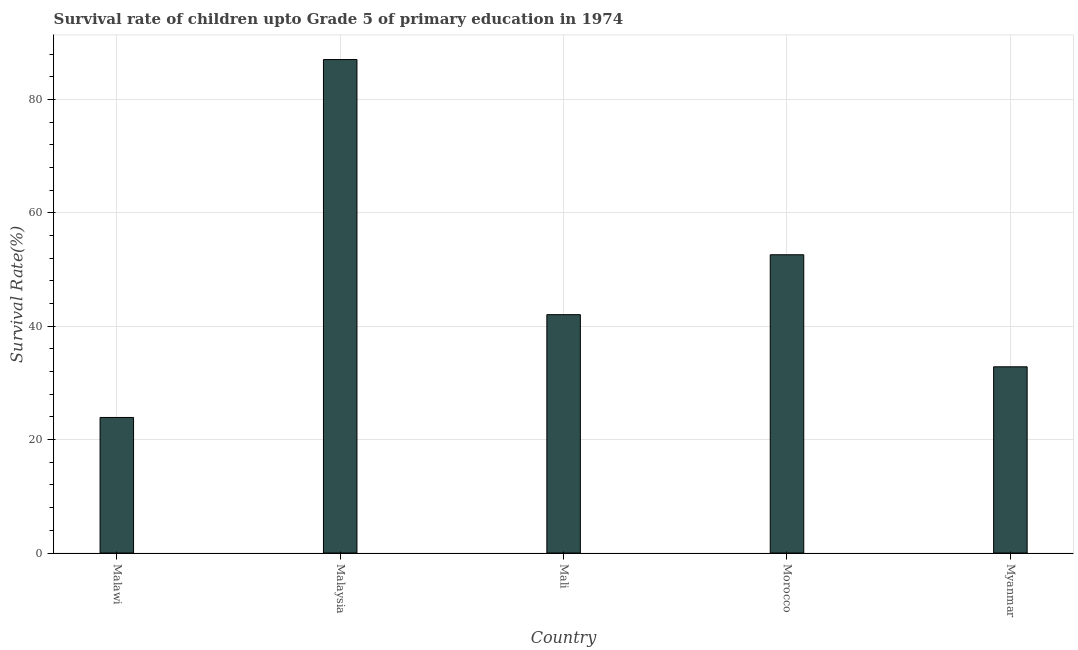Does the graph contain any zero values?
Your answer should be very brief. No. What is the title of the graph?
Ensure brevity in your answer.  Survival rate of children upto Grade 5 of primary education in 1974 . What is the label or title of the X-axis?
Provide a succinct answer. Country. What is the label or title of the Y-axis?
Your answer should be very brief. Survival Rate(%). What is the survival rate in Malaysia?
Ensure brevity in your answer.  87.03. Across all countries, what is the maximum survival rate?
Offer a terse response. 87.03. Across all countries, what is the minimum survival rate?
Your answer should be very brief. 23.91. In which country was the survival rate maximum?
Offer a terse response. Malaysia. In which country was the survival rate minimum?
Make the answer very short. Malawi. What is the sum of the survival rate?
Your answer should be compact. 238.41. What is the difference between the survival rate in Malawi and Mali?
Your answer should be compact. -18.13. What is the average survival rate per country?
Your answer should be compact. 47.68. What is the median survival rate?
Give a very brief answer. 42.04. What is the ratio of the survival rate in Malawi to that in Malaysia?
Give a very brief answer. 0.28. Is the survival rate in Malawi less than that in Mali?
Ensure brevity in your answer.  Yes. Is the difference between the survival rate in Malaysia and Mali greater than the difference between any two countries?
Your response must be concise. No. What is the difference between the highest and the second highest survival rate?
Give a very brief answer. 34.43. Is the sum of the survival rate in Malawi and Mali greater than the maximum survival rate across all countries?
Offer a terse response. No. What is the difference between the highest and the lowest survival rate?
Ensure brevity in your answer.  63.12. In how many countries, is the survival rate greater than the average survival rate taken over all countries?
Keep it short and to the point. 2. How many bars are there?
Offer a very short reply. 5. What is the difference between two consecutive major ticks on the Y-axis?
Your response must be concise. 20. What is the Survival Rate(%) of Malawi?
Offer a very short reply. 23.91. What is the Survival Rate(%) in Malaysia?
Your answer should be compact. 87.03. What is the Survival Rate(%) in Mali?
Your answer should be very brief. 42.04. What is the Survival Rate(%) of Morocco?
Give a very brief answer. 52.6. What is the Survival Rate(%) in Myanmar?
Ensure brevity in your answer.  32.84. What is the difference between the Survival Rate(%) in Malawi and Malaysia?
Offer a very short reply. -63.12. What is the difference between the Survival Rate(%) in Malawi and Mali?
Ensure brevity in your answer.  -18.13. What is the difference between the Survival Rate(%) in Malawi and Morocco?
Your answer should be compact. -28.69. What is the difference between the Survival Rate(%) in Malawi and Myanmar?
Offer a very short reply. -8.93. What is the difference between the Survival Rate(%) in Malaysia and Mali?
Your answer should be compact. 44.99. What is the difference between the Survival Rate(%) in Malaysia and Morocco?
Provide a short and direct response. 34.43. What is the difference between the Survival Rate(%) in Malaysia and Myanmar?
Provide a short and direct response. 54.19. What is the difference between the Survival Rate(%) in Mali and Morocco?
Your answer should be compact. -10.56. What is the difference between the Survival Rate(%) in Mali and Myanmar?
Make the answer very short. 9.19. What is the difference between the Survival Rate(%) in Morocco and Myanmar?
Your answer should be compact. 19.76. What is the ratio of the Survival Rate(%) in Malawi to that in Malaysia?
Your answer should be compact. 0.28. What is the ratio of the Survival Rate(%) in Malawi to that in Mali?
Provide a short and direct response. 0.57. What is the ratio of the Survival Rate(%) in Malawi to that in Morocco?
Keep it short and to the point. 0.46. What is the ratio of the Survival Rate(%) in Malawi to that in Myanmar?
Make the answer very short. 0.73. What is the ratio of the Survival Rate(%) in Malaysia to that in Mali?
Ensure brevity in your answer.  2.07. What is the ratio of the Survival Rate(%) in Malaysia to that in Morocco?
Make the answer very short. 1.65. What is the ratio of the Survival Rate(%) in Malaysia to that in Myanmar?
Offer a very short reply. 2.65. What is the ratio of the Survival Rate(%) in Mali to that in Morocco?
Your response must be concise. 0.8. What is the ratio of the Survival Rate(%) in Mali to that in Myanmar?
Ensure brevity in your answer.  1.28. What is the ratio of the Survival Rate(%) in Morocco to that in Myanmar?
Your answer should be very brief. 1.6. 